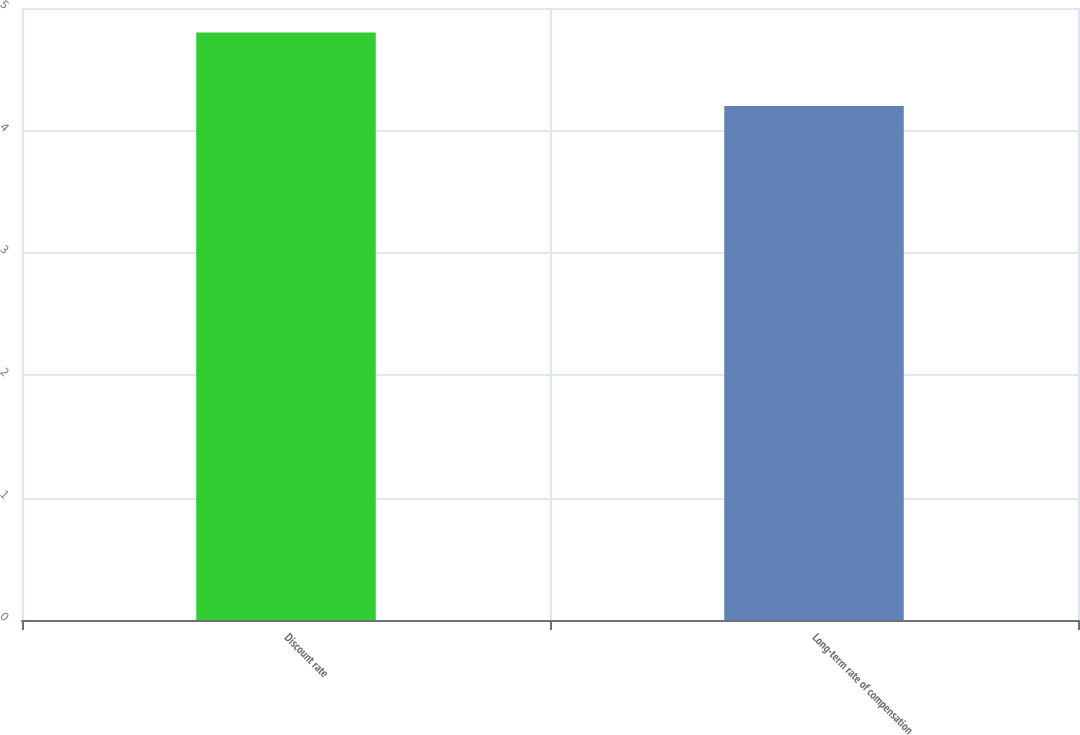Convert chart to OTSL. <chart><loc_0><loc_0><loc_500><loc_500><bar_chart><fcel>Discount rate<fcel>Long-term rate of compensation<nl><fcel>4.8<fcel>4.2<nl></chart> 